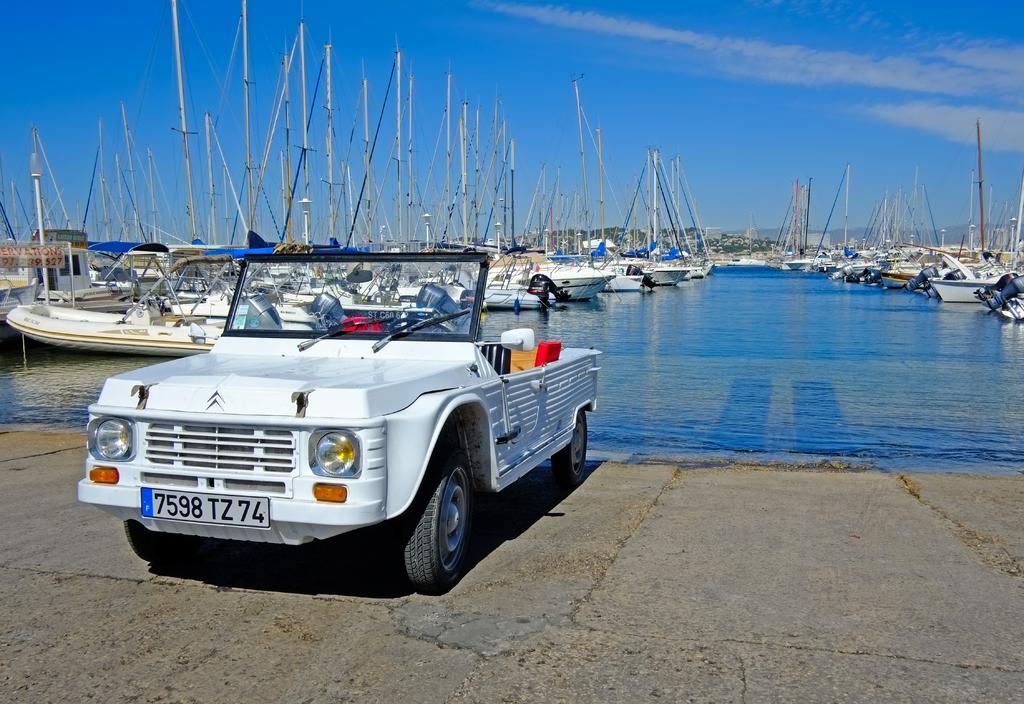In one or two sentences, can you explain what this image depicts? In this image I can see boats on water. Here I can see a vehicle which is white in color. In the background I can see the sky. 